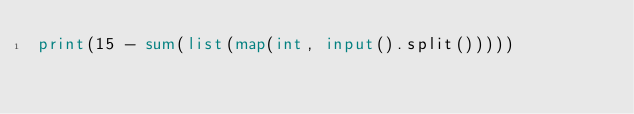<code> <loc_0><loc_0><loc_500><loc_500><_Python_>print(15 - sum(list(map(int, input().split()))))</code> 